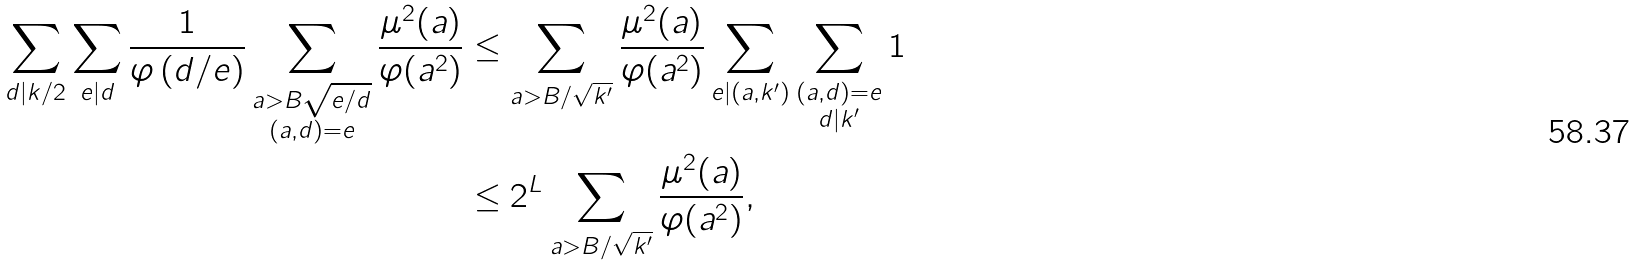<formula> <loc_0><loc_0><loc_500><loc_500>\sum _ { d | k / 2 } \sum _ { e | d } \frac { 1 } { \varphi \left ( d / e \right ) } \sum _ { \substack { a > B \sqrt { e / d } \\ ( a , d ) = e } } \frac { \mu ^ { 2 } ( a ) } { \varphi ( a ^ { 2 } ) } & \leq \sum _ { a > B / \sqrt { k ^ { \prime } } } \frac { \mu ^ { 2 } ( a ) } { \varphi ( a ^ { 2 } ) } \sum _ { e | ( a , k ^ { \prime } ) } \sum _ { \substack { ( a , d ) = e \\ d | k ^ { \prime } } } 1 \\ & \leq 2 ^ { L } \sum _ { a > B / \sqrt { k ^ { \prime } } } \frac { \mu ^ { 2 } ( a ) } { \varphi ( a ^ { 2 } ) } ,</formula> 